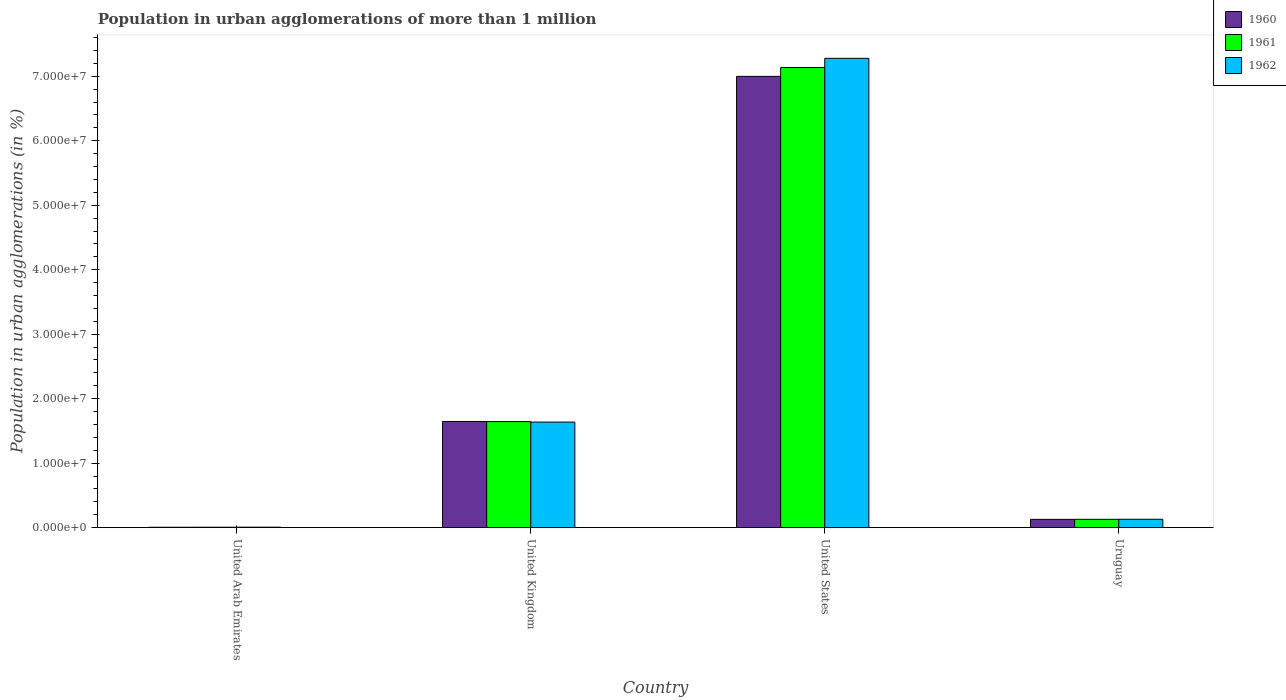How many different coloured bars are there?
Your answer should be compact. 3. Are the number of bars on each tick of the X-axis equal?
Provide a short and direct response. Yes. How many bars are there on the 3rd tick from the left?
Your response must be concise. 3. How many bars are there on the 3rd tick from the right?
Offer a terse response. 3. What is the label of the 2nd group of bars from the left?
Provide a succinct answer. United Kingdom. What is the population in urban agglomerations in 1962 in United Kingdom?
Keep it short and to the point. 1.64e+07. Across all countries, what is the maximum population in urban agglomerations in 1960?
Offer a very short reply. 7.00e+07. Across all countries, what is the minimum population in urban agglomerations in 1962?
Provide a succinct answer. 7.17e+04. In which country was the population in urban agglomerations in 1962 maximum?
Your response must be concise. United States. In which country was the population in urban agglomerations in 1962 minimum?
Your answer should be very brief. United Arab Emirates. What is the total population in urban agglomerations in 1961 in the graph?
Your response must be concise. 8.92e+07. What is the difference between the population in urban agglomerations in 1961 in United Arab Emirates and that in Uruguay?
Ensure brevity in your answer.  -1.23e+06. What is the difference between the population in urban agglomerations in 1962 in United Arab Emirates and the population in urban agglomerations in 1960 in United Kingdom?
Make the answer very short. -1.64e+07. What is the average population in urban agglomerations in 1962 per country?
Give a very brief answer. 2.26e+07. What is the difference between the population in urban agglomerations of/in 1962 and population in urban agglomerations of/in 1961 in United Kingdom?
Your answer should be compact. -8.21e+04. What is the ratio of the population in urban agglomerations in 1962 in United States to that in Uruguay?
Your response must be concise. 55.98. Is the population in urban agglomerations in 1961 in United Arab Emirates less than that in United States?
Keep it short and to the point. Yes. What is the difference between the highest and the second highest population in urban agglomerations in 1962?
Keep it short and to the point. 7.15e+07. What is the difference between the highest and the lowest population in urban agglomerations in 1962?
Your response must be concise. 7.27e+07. In how many countries, is the population in urban agglomerations in 1960 greater than the average population in urban agglomerations in 1960 taken over all countries?
Offer a very short reply. 1. What does the 3rd bar from the left in United Kingdom represents?
Your answer should be compact. 1962. Are all the bars in the graph horizontal?
Your answer should be very brief. No. How many countries are there in the graph?
Provide a short and direct response. 4. What is the difference between two consecutive major ticks on the Y-axis?
Your response must be concise. 1.00e+07. Does the graph contain any zero values?
Give a very brief answer. No. Does the graph contain grids?
Ensure brevity in your answer.  No. What is the title of the graph?
Make the answer very short. Population in urban agglomerations of more than 1 million. Does "1960" appear as one of the legend labels in the graph?
Your response must be concise. Yes. What is the label or title of the X-axis?
Your response must be concise. Country. What is the label or title of the Y-axis?
Give a very brief answer. Population in urban agglomerations (in %). What is the Population in urban agglomerations (in %) of 1960 in United Arab Emirates?
Provide a short and direct response. 5.97e+04. What is the Population in urban agglomerations (in %) in 1961 in United Arab Emirates?
Your answer should be compact. 6.54e+04. What is the Population in urban agglomerations (in %) of 1962 in United Arab Emirates?
Give a very brief answer. 7.17e+04. What is the Population in urban agglomerations (in %) in 1960 in United Kingdom?
Offer a terse response. 1.65e+07. What is the Population in urban agglomerations (in %) in 1961 in United Kingdom?
Give a very brief answer. 1.64e+07. What is the Population in urban agglomerations (in %) in 1962 in United Kingdom?
Ensure brevity in your answer.  1.64e+07. What is the Population in urban agglomerations (in %) of 1960 in United States?
Keep it short and to the point. 7.00e+07. What is the Population in urban agglomerations (in %) in 1961 in United States?
Ensure brevity in your answer.  7.14e+07. What is the Population in urban agglomerations (in %) of 1962 in United States?
Provide a short and direct response. 7.28e+07. What is the Population in urban agglomerations (in %) in 1960 in Uruguay?
Offer a very short reply. 1.28e+06. What is the Population in urban agglomerations (in %) of 1961 in Uruguay?
Your response must be concise. 1.29e+06. What is the Population in urban agglomerations (in %) in 1962 in Uruguay?
Provide a succinct answer. 1.30e+06. Across all countries, what is the maximum Population in urban agglomerations (in %) in 1960?
Ensure brevity in your answer.  7.00e+07. Across all countries, what is the maximum Population in urban agglomerations (in %) in 1961?
Give a very brief answer. 7.14e+07. Across all countries, what is the maximum Population in urban agglomerations (in %) in 1962?
Provide a short and direct response. 7.28e+07. Across all countries, what is the minimum Population in urban agglomerations (in %) in 1960?
Give a very brief answer. 5.97e+04. Across all countries, what is the minimum Population in urban agglomerations (in %) of 1961?
Make the answer very short. 6.54e+04. Across all countries, what is the minimum Population in urban agglomerations (in %) in 1962?
Offer a terse response. 7.17e+04. What is the total Population in urban agglomerations (in %) of 1960 in the graph?
Your response must be concise. 8.78e+07. What is the total Population in urban agglomerations (in %) in 1961 in the graph?
Your answer should be very brief. 8.92e+07. What is the total Population in urban agglomerations (in %) in 1962 in the graph?
Ensure brevity in your answer.  9.05e+07. What is the difference between the Population in urban agglomerations (in %) in 1960 in United Arab Emirates and that in United Kingdom?
Your answer should be very brief. -1.64e+07. What is the difference between the Population in urban agglomerations (in %) in 1961 in United Arab Emirates and that in United Kingdom?
Provide a short and direct response. -1.64e+07. What is the difference between the Population in urban agglomerations (in %) in 1962 in United Arab Emirates and that in United Kingdom?
Provide a short and direct response. -1.63e+07. What is the difference between the Population in urban agglomerations (in %) in 1960 in United Arab Emirates and that in United States?
Give a very brief answer. -6.99e+07. What is the difference between the Population in urban agglomerations (in %) of 1961 in United Arab Emirates and that in United States?
Make the answer very short. -7.13e+07. What is the difference between the Population in urban agglomerations (in %) in 1962 in United Arab Emirates and that in United States?
Provide a succinct answer. -7.27e+07. What is the difference between the Population in urban agglomerations (in %) in 1960 in United Arab Emirates and that in Uruguay?
Offer a terse response. -1.23e+06. What is the difference between the Population in urban agglomerations (in %) of 1961 in United Arab Emirates and that in Uruguay?
Offer a very short reply. -1.23e+06. What is the difference between the Population in urban agglomerations (in %) in 1962 in United Arab Emirates and that in Uruguay?
Provide a succinct answer. -1.23e+06. What is the difference between the Population in urban agglomerations (in %) of 1960 in United Kingdom and that in United States?
Keep it short and to the point. -5.35e+07. What is the difference between the Population in urban agglomerations (in %) of 1961 in United Kingdom and that in United States?
Offer a very short reply. -5.49e+07. What is the difference between the Population in urban agglomerations (in %) in 1962 in United Kingdom and that in United States?
Offer a terse response. -5.64e+07. What is the difference between the Population in urban agglomerations (in %) in 1960 in United Kingdom and that in Uruguay?
Offer a terse response. 1.52e+07. What is the difference between the Population in urban agglomerations (in %) of 1961 in United Kingdom and that in Uruguay?
Keep it short and to the point. 1.52e+07. What is the difference between the Population in urban agglomerations (in %) of 1962 in United Kingdom and that in Uruguay?
Ensure brevity in your answer.  1.51e+07. What is the difference between the Population in urban agglomerations (in %) in 1960 in United States and that in Uruguay?
Keep it short and to the point. 6.87e+07. What is the difference between the Population in urban agglomerations (in %) of 1961 in United States and that in Uruguay?
Provide a succinct answer. 7.01e+07. What is the difference between the Population in urban agglomerations (in %) of 1962 in United States and that in Uruguay?
Offer a terse response. 7.15e+07. What is the difference between the Population in urban agglomerations (in %) in 1960 in United Arab Emirates and the Population in urban agglomerations (in %) in 1961 in United Kingdom?
Provide a succinct answer. -1.64e+07. What is the difference between the Population in urban agglomerations (in %) of 1960 in United Arab Emirates and the Population in urban agglomerations (in %) of 1962 in United Kingdom?
Offer a terse response. -1.63e+07. What is the difference between the Population in urban agglomerations (in %) of 1961 in United Arab Emirates and the Population in urban agglomerations (in %) of 1962 in United Kingdom?
Offer a terse response. -1.63e+07. What is the difference between the Population in urban agglomerations (in %) of 1960 in United Arab Emirates and the Population in urban agglomerations (in %) of 1961 in United States?
Provide a short and direct response. -7.13e+07. What is the difference between the Population in urban agglomerations (in %) of 1960 in United Arab Emirates and the Population in urban agglomerations (in %) of 1962 in United States?
Keep it short and to the point. -7.27e+07. What is the difference between the Population in urban agglomerations (in %) in 1961 in United Arab Emirates and the Population in urban agglomerations (in %) in 1962 in United States?
Keep it short and to the point. -7.27e+07. What is the difference between the Population in urban agglomerations (in %) in 1960 in United Arab Emirates and the Population in urban agglomerations (in %) in 1961 in Uruguay?
Your answer should be compact. -1.23e+06. What is the difference between the Population in urban agglomerations (in %) of 1960 in United Arab Emirates and the Population in urban agglomerations (in %) of 1962 in Uruguay?
Your answer should be very brief. -1.24e+06. What is the difference between the Population in urban agglomerations (in %) of 1961 in United Arab Emirates and the Population in urban agglomerations (in %) of 1962 in Uruguay?
Provide a succinct answer. -1.23e+06. What is the difference between the Population in urban agglomerations (in %) in 1960 in United Kingdom and the Population in urban agglomerations (in %) in 1961 in United States?
Keep it short and to the point. -5.49e+07. What is the difference between the Population in urban agglomerations (in %) of 1960 in United Kingdom and the Population in urban agglomerations (in %) of 1962 in United States?
Your response must be concise. -5.63e+07. What is the difference between the Population in urban agglomerations (in %) in 1961 in United Kingdom and the Population in urban agglomerations (in %) in 1962 in United States?
Your response must be concise. -5.63e+07. What is the difference between the Population in urban agglomerations (in %) of 1960 in United Kingdom and the Population in urban agglomerations (in %) of 1961 in Uruguay?
Keep it short and to the point. 1.52e+07. What is the difference between the Population in urban agglomerations (in %) in 1960 in United Kingdom and the Population in urban agglomerations (in %) in 1962 in Uruguay?
Make the answer very short. 1.52e+07. What is the difference between the Population in urban agglomerations (in %) in 1961 in United Kingdom and the Population in urban agglomerations (in %) in 1962 in Uruguay?
Give a very brief answer. 1.51e+07. What is the difference between the Population in urban agglomerations (in %) of 1960 in United States and the Population in urban agglomerations (in %) of 1961 in Uruguay?
Offer a terse response. 6.87e+07. What is the difference between the Population in urban agglomerations (in %) in 1960 in United States and the Population in urban agglomerations (in %) in 1962 in Uruguay?
Provide a succinct answer. 6.87e+07. What is the difference between the Population in urban agglomerations (in %) of 1961 in United States and the Population in urban agglomerations (in %) of 1962 in Uruguay?
Your response must be concise. 7.01e+07. What is the average Population in urban agglomerations (in %) in 1960 per country?
Make the answer very short. 2.19e+07. What is the average Population in urban agglomerations (in %) in 1961 per country?
Ensure brevity in your answer.  2.23e+07. What is the average Population in urban agglomerations (in %) in 1962 per country?
Provide a succinct answer. 2.26e+07. What is the difference between the Population in urban agglomerations (in %) in 1960 and Population in urban agglomerations (in %) in 1961 in United Arab Emirates?
Your response must be concise. -5644. What is the difference between the Population in urban agglomerations (in %) in 1960 and Population in urban agglomerations (in %) in 1962 in United Arab Emirates?
Your answer should be compact. -1.19e+04. What is the difference between the Population in urban agglomerations (in %) in 1961 and Population in urban agglomerations (in %) in 1962 in United Arab Emirates?
Offer a very short reply. -6289. What is the difference between the Population in urban agglomerations (in %) in 1960 and Population in urban agglomerations (in %) in 1961 in United Kingdom?
Your response must be concise. 1.49e+04. What is the difference between the Population in urban agglomerations (in %) of 1960 and Population in urban agglomerations (in %) of 1962 in United Kingdom?
Keep it short and to the point. 9.70e+04. What is the difference between the Population in urban agglomerations (in %) in 1961 and Population in urban agglomerations (in %) in 1962 in United Kingdom?
Provide a short and direct response. 8.21e+04. What is the difference between the Population in urban agglomerations (in %) of 1960 and Population in urban agglomerations (in %) of 1961 in United States?
Make the answer very short. -1.38e+06. What is the difference between the Population in urban agglomerations (in %) in 1960 and Population in urban agglomerations (in %) in 1962 in United States?
Your answer should be very brief. -2.80e+06. What is the difference between the Population in urban agglomerations (in %) of 1961 and Population in urban agglomerations (in %) of 1962 in United States?
Provide a short and direct response. -1.42e+06. What is the difference between the Population in urban agglomerations (in %) of 1960 and Population in urban agglomerations (in %) of 1961 in Uruguay?
Provide a short and direct response. -7522. What is the difference between the Population in urban agglomerations (in %) in 1960 and Population in urban agglomerations (in %) in 1962 in Uruguay?
Give a very brief answer. -1.51e+04. What is the difference between the Population in urban agglomerations (in %) in 1961 and Population in urban agglomerations (in %) in 1962 in Uruguay?
Ensure brevity in your answer.  -7578. What is the ratio of the Population in urban agglomerations (in %) in 1960 in United Arab Emirates to that in United Kingdom?
Your answer should be very brief. 0. What is the ratio of the Population in urban agglomerations (in %) in 1961 in United Arab Emirates to that in United Kingdom?
Your answer should be compact. 0. What is the ratio of the Population in urban agglomerations (in %) in 1962 in United Arab Emirates to that in United Kingdom?
Offer a very short reply. 0. What is the ratio of the Population in urban agglomerations (in %) of 1960 in United Arab Emirates to that in United States?
Offer a very short reply. 0. What is the ratio of the Population in urban agglomerations (in %) in 1961 in United Arab Emirates to that in United States?
Provide a succinct answer. 0. What is the ratio of the Population in urban agglomerations (in %) of 1962 in United Arab Emirates to that in United States?
Your answer should be compact. 0. What is the ratio of the Population in urban agglomerations (in %) of 1960 in United Arab Emirates to that in Uruguay?
Your answer should be compact. 0.05. What is the ratio of the Population in urban agglomerations (in %) in 1961 in United Arab Emirates to that in Uruguay?
Provide a succinct answer. 0.05. What is the ratio of the Population in urban agglomerations (in %) of 1962 in United Arab Emirates to that in Uruguay?
Offer a terse response. 0.06. What is the ratio of the Population in urban agglomerations (in %) of 1960 in United Kingdom to that in United States?
Offer a very short reply. 0.24. What is the ratio of the Population in urban agglomerations (in %) in 1961 in United Kingdom to that in United States?
Your response must be concise. 0.23. What is the ratio of the Population in urban agglomerations (in %) of 1962 in United Kingdom to that in United States?
Provide a short and direct response. 0.22. What is the ratio of the Population in urban agglomerations (in %) in 1960 in United Kingdom to that in Uruguay?
Make the answer very short. 12.81. What is the ratio of the Population in urban agglomerations (in %) of 1961 in United Kingdom to that in Uruguay?
Ensure brevity in your answer.  12.73. What is the ratio of the Population in urban agglomerations (in %) of 1962 in United Kingdom to that in Uruguay?
Make the answer very short. 12.59. What is the ratio of the Population in urban agglomerations (in %) of 1960 in United States to that in Uruguay?
Offer a terse response. 54.46. What is the ratio of the Population in urban agglomerations (in %) in 1961 in United States to that in Uruguay?
Offer a very short reply. 55.21. What is the ratio of the Population in urban agglomerations (in %) in 1962 in United States to that in Uruguay?
Provide a short and direct response. 55.98. What is the difference between the highest and the second highest Population in urban agglomerations (in %) of 1960?
Make the answer very short. 5.35e+07. What is the difference between the highest and the second highest Population in urban agglomerations (in %) in 1961?
Your answer should be compact. 5.49e+07. What is the difference between the highest and the second highest Population in urban agglomerations (in %) of 1962?
Make the answer very short. 5.64e+07. What is the difference between the highest and the lowest Population in urban agglomerations (in %) in 1960?
Your answer should be compact. 6.99e+07. What is the difference between the highest and the lowest Population in urban agglomerations (in %) in 1961?
Offer a terse response. 7.13e+07. What is the difference between the highest and the lowest Population in urban agglomerations (in %) in 1962?
Your response must be concise. 7.27e+07. 